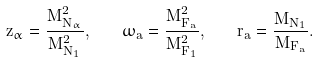<formula> <loc_0><loc_0><loc_500><loc_500>z _ { \alpha } = \frac { M _ { N _ { \alpha } } ^ { 2 } } { M _ { N _ { 1 } } ^ { 2 } } , \quad \omega _ { a } = \frac { M _ { F _ { a } } ^ { 2 } } { M _ { F _ { 1 } } ^ { 2 } } , \quad r _ { a } = \frac { M _ { N _ { 1 } } } { M _ { F _ { a } } } .</formula> 